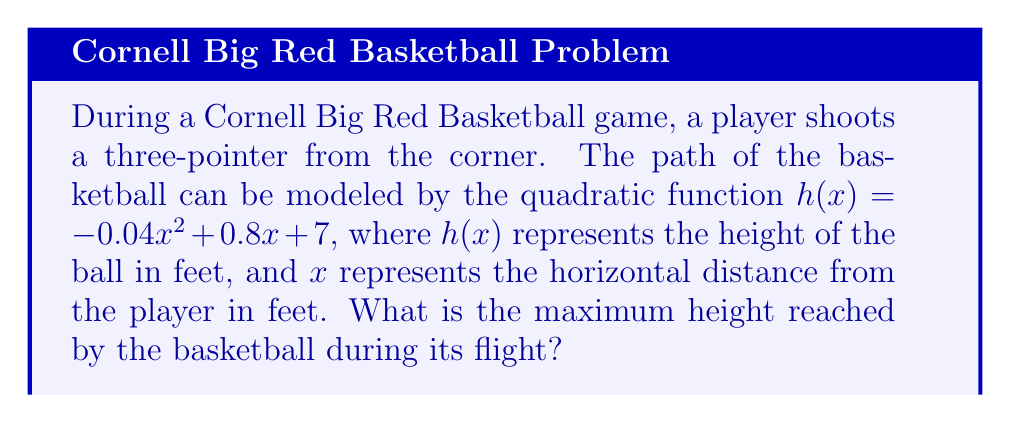Solve this math problem. To find the maximum height of the basketball shot, we need to follow these steps:

1) The quadratic function is in the form $h(x) = ax^2 + bx + c$, where:
   $a = -0.04$
   $b = 0.8$
   $c = 7$

2) For a quadratic function, the x-coordinate of the vertex represents the point where the function reaches its maximum (if $a < 0$) or minimum (if $a > 0$).

3) The formula for the x-coordinate of the vertex is: $x = -\frac{b}{2a}$

4) Substituting our values:
   $x = -\frac{0.8}{2(-0.04)} = -\frac{0.8}{-0.08} = 10$

5) To find the maximum height, we need to calculate $h(10)$:

   $h(10) = -0.04(10)^2 + 0.8(10) + 7$
   $= -0.04(100) + 8 + 7$
   $= -4 + 8 + 7$
   $= 11$

Therefore, the maximum height reached by the basketball is 11 feet.
Answer: 11 feet 